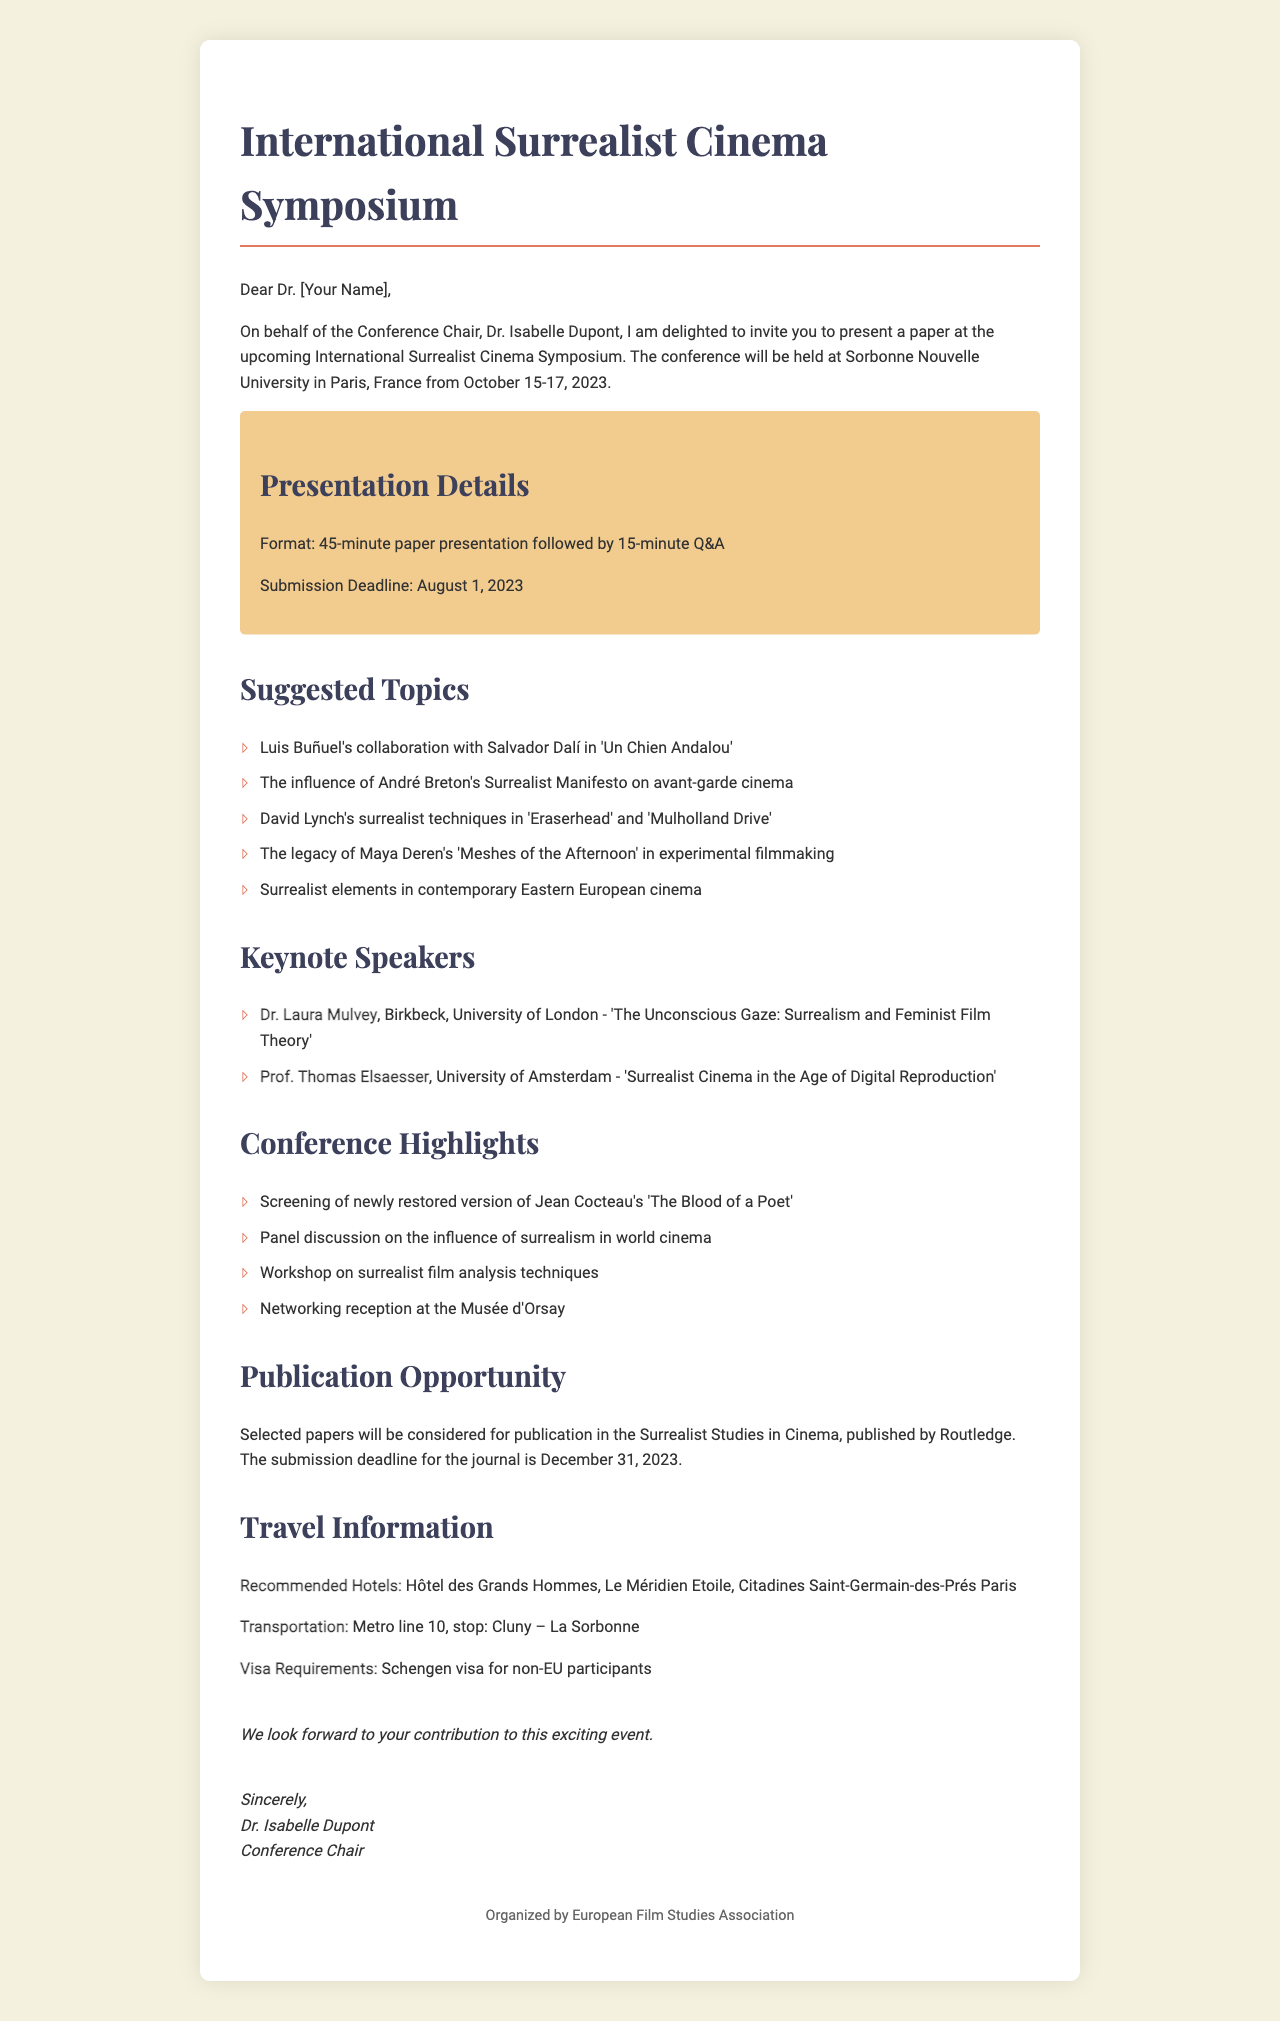What are the dates of the conference? The dates of the conference are mentioned in the document as October 15-17, 2023.
Answer: October 15-17, 2023 Who is the sender of the invitation? The sender of the invitation is identified in the document as Dr. Isabelle Dupont.
Answer: Dr. Isabelle Dupont What is the format of the presentation? The format of the presentation is detailed as a 45-minute paper presentation followed by a 15-minute Q&A.
Answer: 45-minute paper presentation followed by 15-minute Q&A Which hotel is recommended for staying during the conference? The document lists several hotels, and one of them is Hôtel des Grands Hommes.
Answer: Hôtel des Grands Hommes What is the submission deadline for presentation papers? The submission deadline for presentation papers is specified in the document as August 1, 2023.
Answer: August 1, 2023 How many keynote speakers are mentioned in the invitation? The document mentions two keynote speakers in the list presented.
Answer: Two What is the journal mentioned for publication opportunity? The journal specified for publication opportunities in the document is Surrealist Studies in Cinema.
Answer: Surrealist Studies in Cinema What is the main theme of the conference? The main theme of the conference is indicated by its title, which focuses on surrealist cinema.
Answer: Surrealist cinema What is the venue for the conference? The venue for the conference is stated as Sorbonne Nouvelle University.
Answer: Sorbonne Nouvelle University 